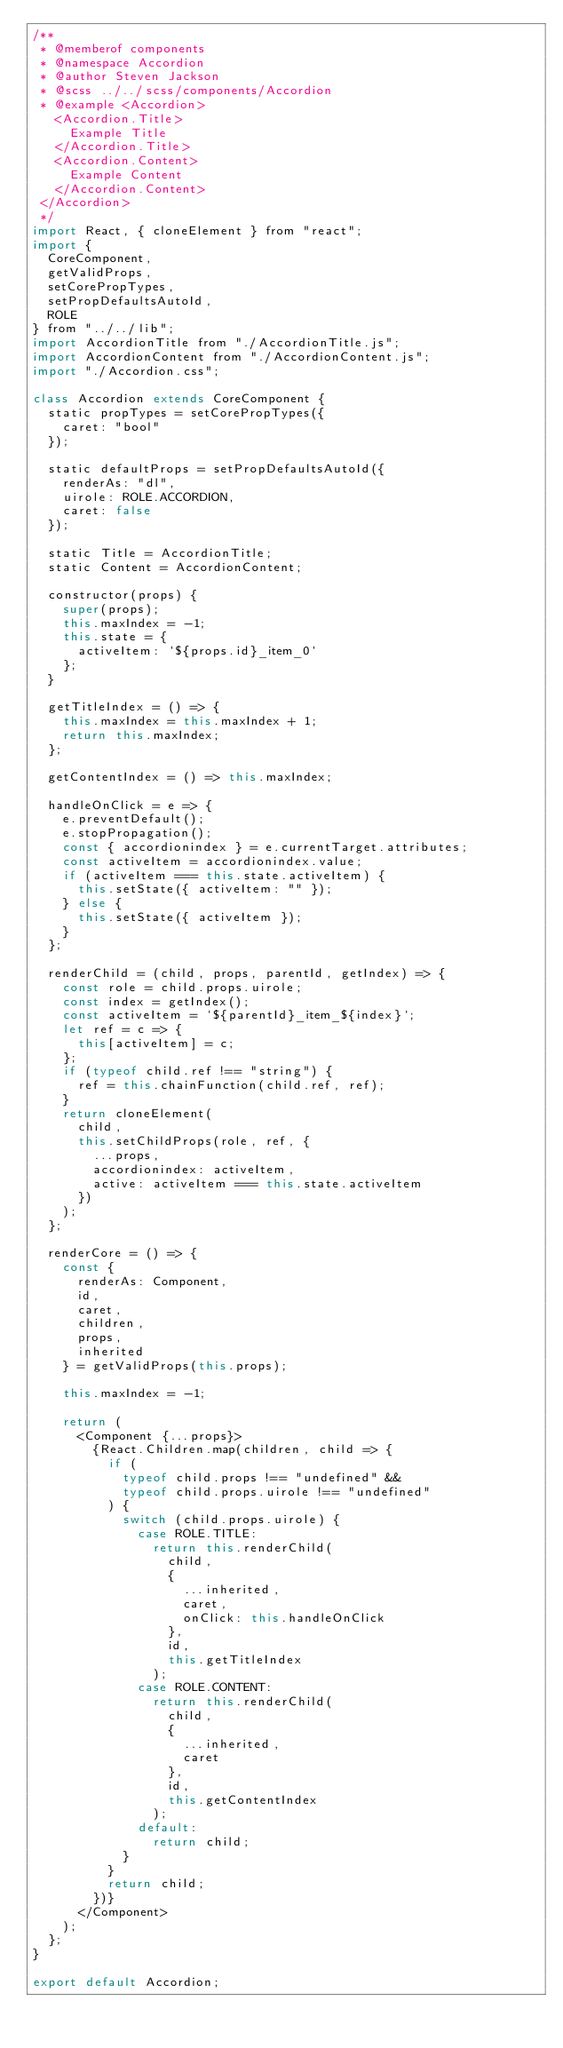Convert code to text. <code><loc_0><loc_0><loc_500><loc_500><_JavaScript_>/**
 * @memberof components
 * @namespace Accordion
 * @author Steven Jackson
 * @scss ../../scss/components/Accordion
 * @example <Accordion>
   <Accordion.Title>
     Example Title
   </Accordion.Title>
   <Accordion.Content>
     Example Content
   </Accordion.Content>
 </Accordion>
 */
import React, { cloneElement } from "react";
import {
  CoreComponent,
  getValidProps,
  setCorePropTypes,
  setPropDefaultsAutoId,
  ROLE
} from "../../lib";
import AccordionTitle from "./AccordionTitle.js";
import AccordionContent from "./AccordionContent.js";
import "./Accordion.css";

class Accordion extends CoreComponent {
  static propTypes = setCorePropTypes({
    caret: "bool"
  });

  static defaultProps = setPropDefaultsAutoId({
    renderAs: "dl",
    uirole: ROLE.ACCORDION,
    caret: false
  });

  static Title = AccordionTitle;
  static Content = AccordionContent;

  constructor(props) {
    super(props);
    this.maxIndex = -1;
    this.state = {
      activeItem: `${props.id}_item_0`
    };
  }

  getTitleIndex = () => {
    this.maxIndex = this.maxIndex + 1;
    return this.maxIndex;
  };

  getContentIndex = () => this.maxIndex;

  handleOnClick = e => {
    e.preventDefault();
    e.stopPropagation();
    const { accordionindex } = e.currentTarget.attributes;
    const activeItem = accordionindex.value;
    if (activeItem === this.state.activeItem) {
      this.setState({ activeItem: "" });
    } else {
      this.setState({ activeItem });
    }
  };

  renderChild = (child, props, parentId, getIndex) => {
    const role = child.props.uirole;
    const index = getIndex();
    const activeItem = `${parentId}_item_${index}`;
    let ref = c => {
      this[activeItem] = c;
    };
    if (typeof child.ref !== "string") {
      ref = this.chainFunction(child.ref, ref);
    }
    return cloneElement(
      child,
      this.setChildProps(role, ref, {
        ...props,
        accordionindex: activeItem,
        active: activeItem === this.state.activeItem
      })
    );
  };

  renderCore = () => {
    const {
      renderAs: Component,
      id,
      caret,
      children,
      props,
      inherited
    } = getValidProps(this.props);

    this.maxIndex = -1;

    return (
      <Component {...props}>
        {React.Children.map(children, child => {
          if (
            typeof child.props !== "undefined" &&
            typeof child.props.uirole !== "undefined"
          ) {
            switch (child.props.uirole) {
              case ROLE.TITLE:
                return this.renderChild(
                  child,
                  {
                    ...inherited,
                    caret,
                    onClick: this.handleOnClick
                  },
                  id,
                  this.getTitleIndex
                );
              case ROLE.CONTENT:
                return this.renderChild(
                  child,
                  {
                    ...inherited,
                    caret
                  },
                  id,
                  this.getContentIndex
                );
              default:
                return child;
            }
          }
          return child;
        })}
      </Component>
    );
  };
}

export default Accordion;
</code> 